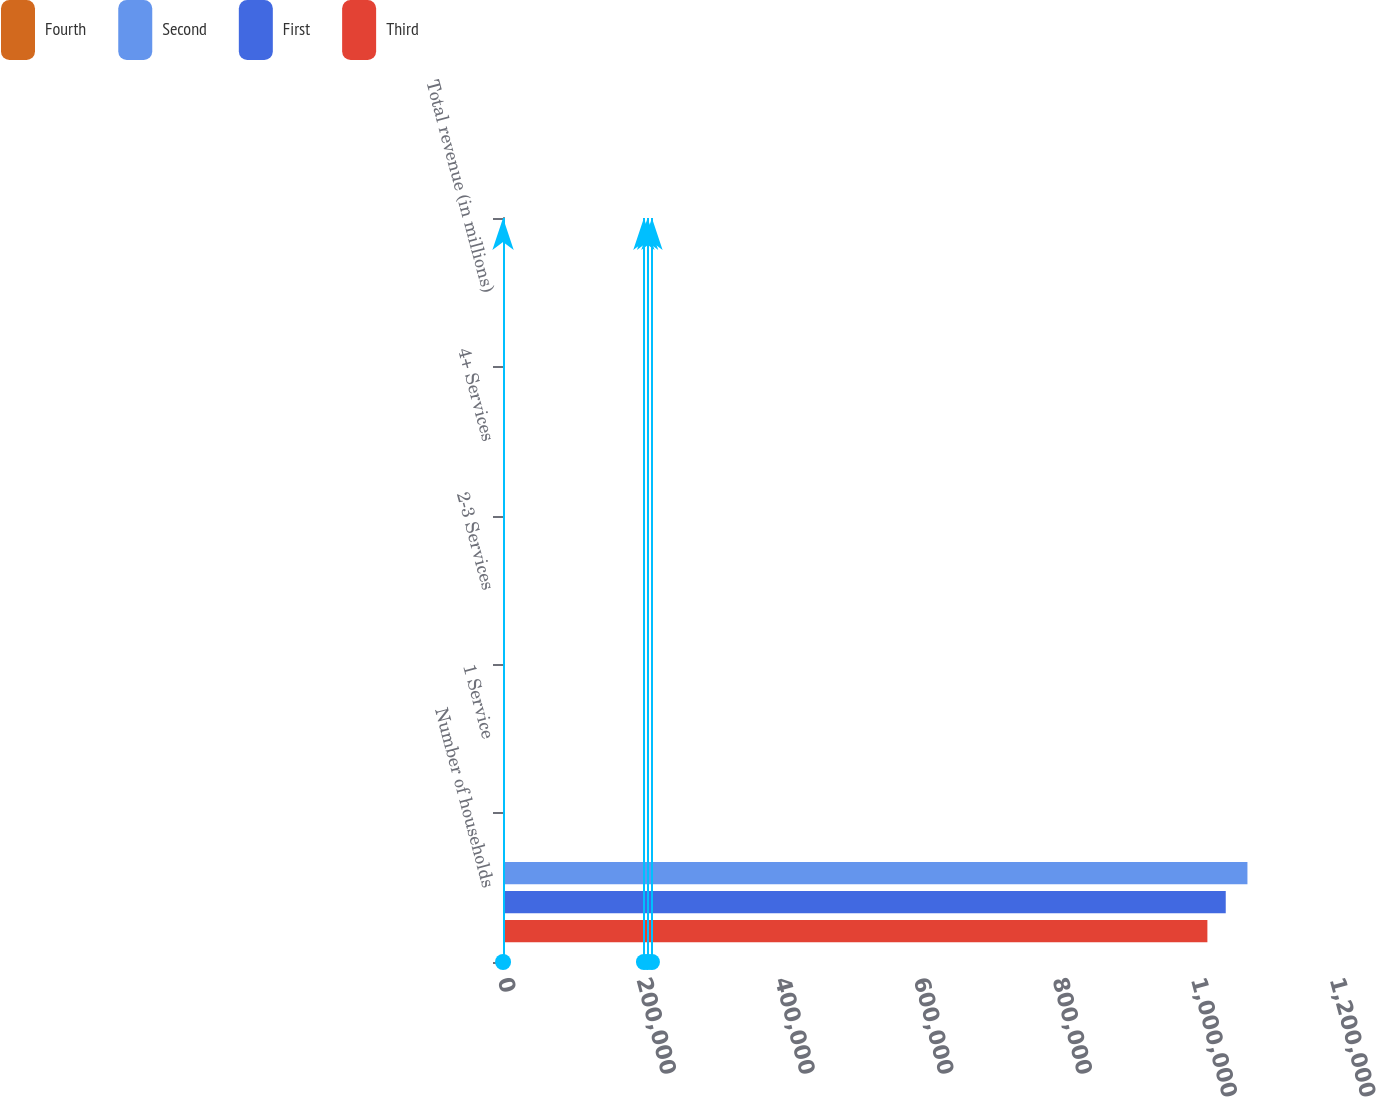Convert chart. <chart><loc_0><loc_0><loc_500><loc_500><stacked_bar_chart><ecel><fcel>Number of households<fcel>1 Service<fcel>2-3 Services<fcel>4+ Services<fcel>Total revenue (in millions)<nl><fcel>Fourth<fcel>71.3<fcel>4.1<fcel>22.4<fcel>73.5<fcel>230.6<nl><fcel>Second<fcel>1.07371e+06<fcel>4.4<fcel>22.8<fcel>72.8<fcel>251.9<nl><fcel>First<fcel>1.04242e+06<fcel>4.5<fcel>24.2<fcel>71.3<fcel>260<nl><fcel>Third<fcel>1.01595e+06<fcel>4.9<fcel>24.6<fcel>70.5<fcel>248.6<nl></chart> 